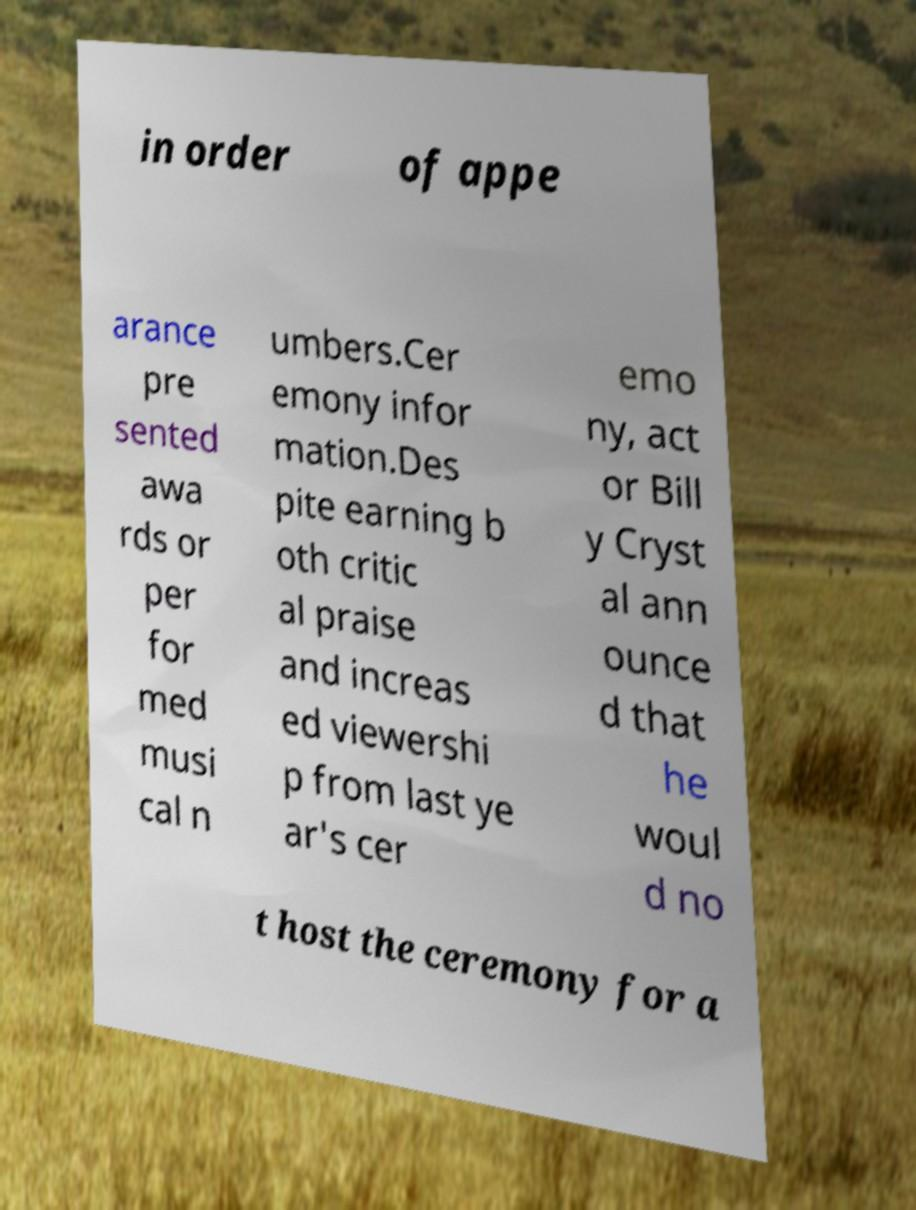What messages or text are displayed in this image? I need them in a readable, typed format. in order of appe arance pre sented awa rds or per for med musi cal n umbers.Cer emony infor mation.Des pite earning b oth critic al praise and increas ed viewershi p from last ye ar's cer emo ny, act or Bill y Cryst al ann ounce d that he woul d no t host the ceremony for a 